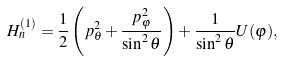Convert formula to latex. <formula><loc_0><loc_0><loc_500><loc_500>H _ { n } ^ { ( 1 ) } = \frac { 1 } { 2 } \left ( p _ { \theta } ^ { 2 } + \frac { p _ { \varphi } ^ { 2 } } { \sin ^ { 2 } \theta } \right ) + \frac { 1 } { \sin ^ { 2 } \theta } U ( \varphi ) ,</formula> 